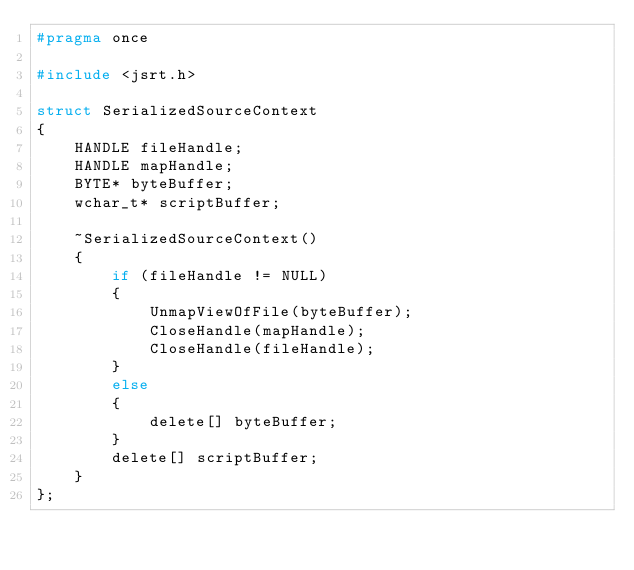<code> <loc_0><loc_0><loc_500><loc_500><_C_>#pragma once

#include <jsrt.h>

struct SerializedSourceContext
{
    HANDLE fileHandle;
    HANDLE mapHandle;
    BYTE* byteBuffer;
    wchar_t* scriptBuffer;

    ~SerializedSourceContext()
    {
        if (fileHandle != NULL)
        {
            UnmapViewOfFile(byteBuffer);
            CloseHandle(mapHandle);
            CloseHandle(fileHandle);
        }
        else
        {
            delete[] byteBuffer;
        }
        delete[] scriptBuffer;
    }
};
</code> 